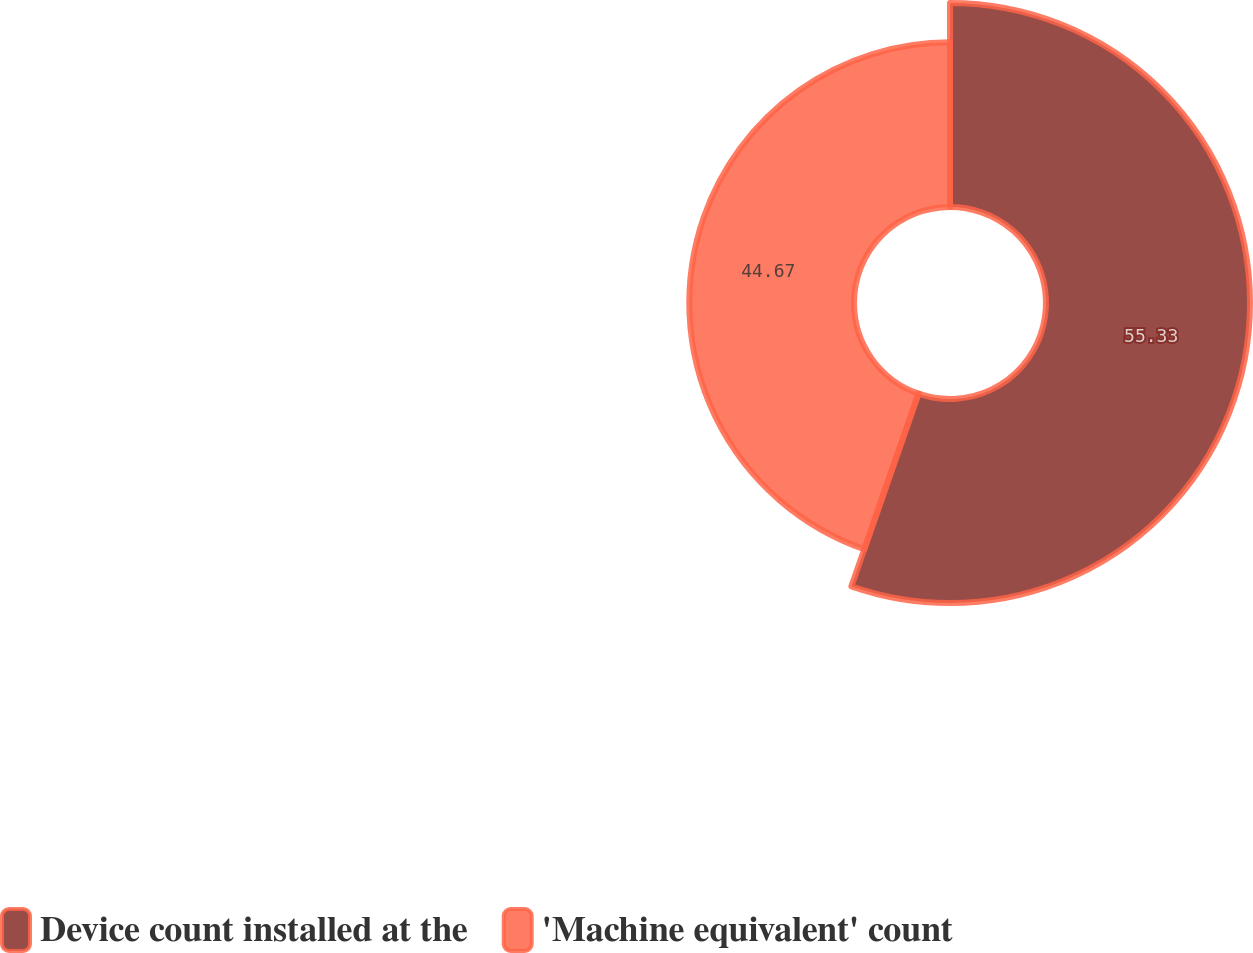Convert chart to OTSL. <chart><loc_0><loc_0><loc_500><loc_500><pie_chart><fcel>Device count installed at the<fcel>'Machine equivalent' count<nl><fcel>55.33%<fcel>44.67%<nl></chart> 